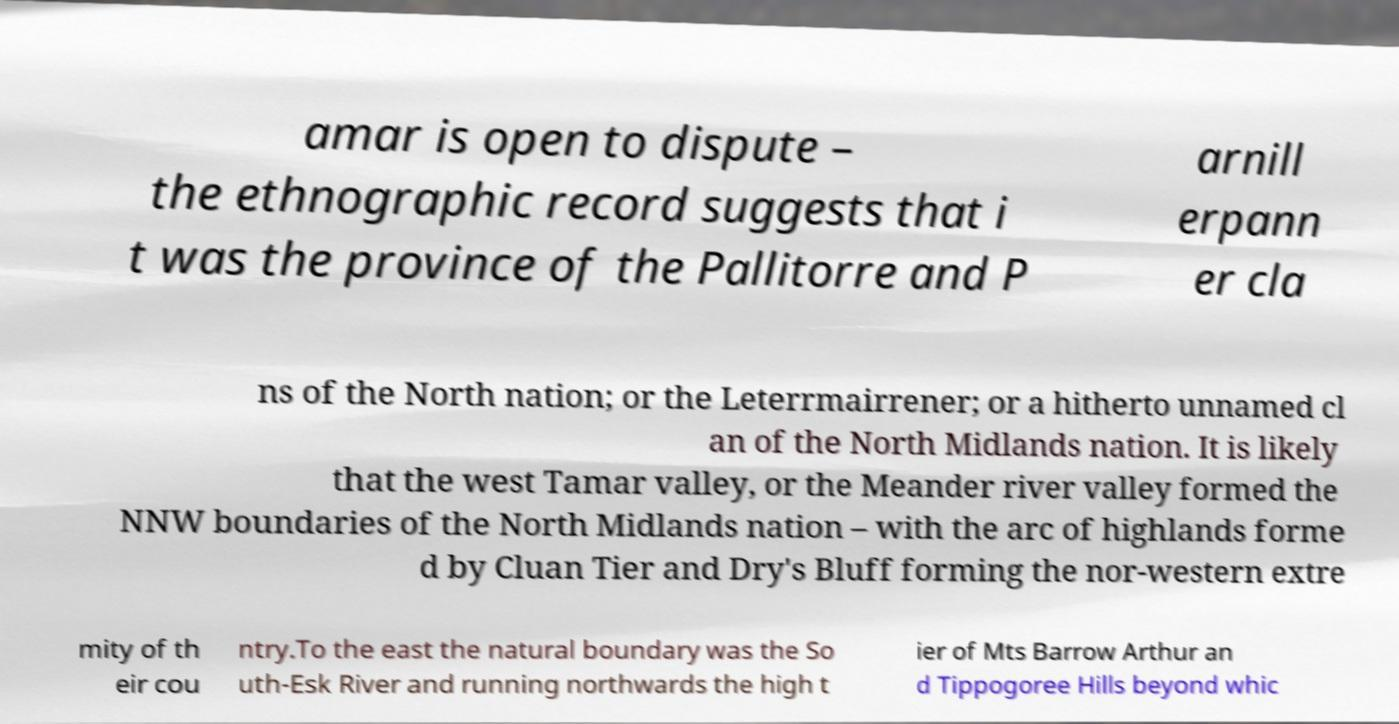What messages or text are displayed in this image? I need them in a readable, typed format. amar is open to dispute – the ethnographic record suggests that i t was the province of the Pallitorre and P arnill erpann er cla ns of the North nation; or the Leterrmairrener; or a hitherto unnamed cl an of the North Midlands nation. It is likely that the west Tamar valley, or the Meander river valley formed the NNW boundaries of the North Midlands nation – with the arc of highlands forme d by Cluan Tier and Dry's Bluff forming the nor-western extre mity of th eir cou ntry.To the east the natural boundary was the So uth-Esk River and running northwards the high t ier of Mts Barrow Arthur an d Tippogoree Hills beyond whic 